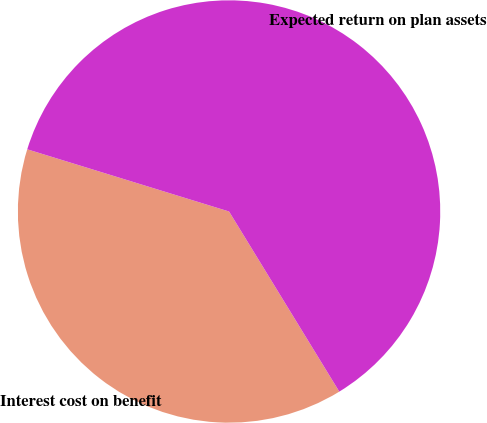Convert chart. <chart><loc_0><loc_0><loc_500><loc_500><pie_chart><fcel>Interest cost on benefit<fcel>Expected return on plan assets<nl><fcel>38.5%<fcel>61.5%<nl></chart> 